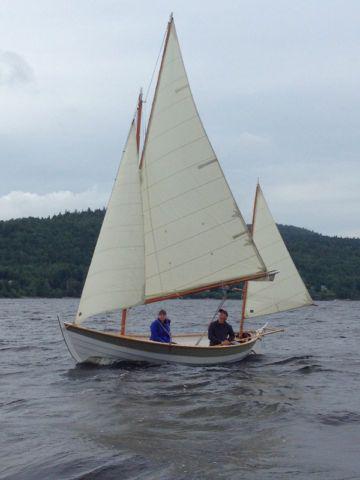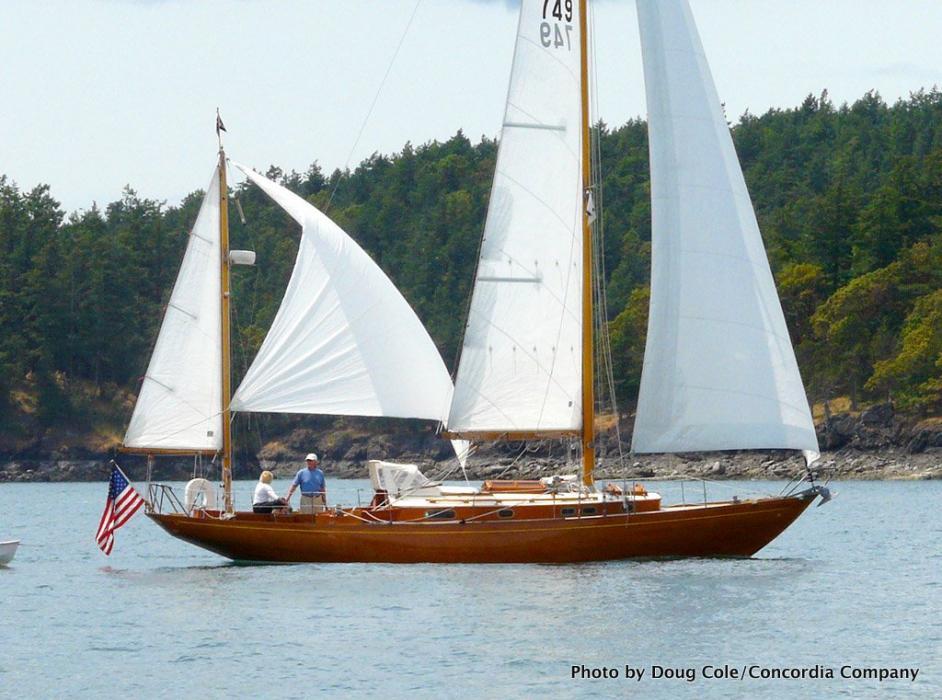The first image is the image on the left, the second image is the image on the right. For the images displayed, is the sentence "There are more boats in the image on the right than the image on the left." factually correct? Answer yes or no. No. The first image is the image on the left, the second image is the image on the right. Analyze the images presented: Is the assertion "An image shows multiple sailboats with unfurled sails." valid? Answer yes or no. No. 